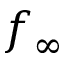Convert formula to latex. <formula><loc_0><loc_0><loc_500><loc_500>f _ { \infty }</formula> 